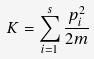<formula> <loc_0><loc_0><loc_500><loc_500>K = \sum _ { i = 1 } ^ { s } \frac { p _ { i } ^ { 2 } } { 2 m }</formula> 